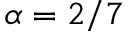<formula> <loc_0><loc_0><loc_500><loc_500>\alpha = 2 / 7</formula> 